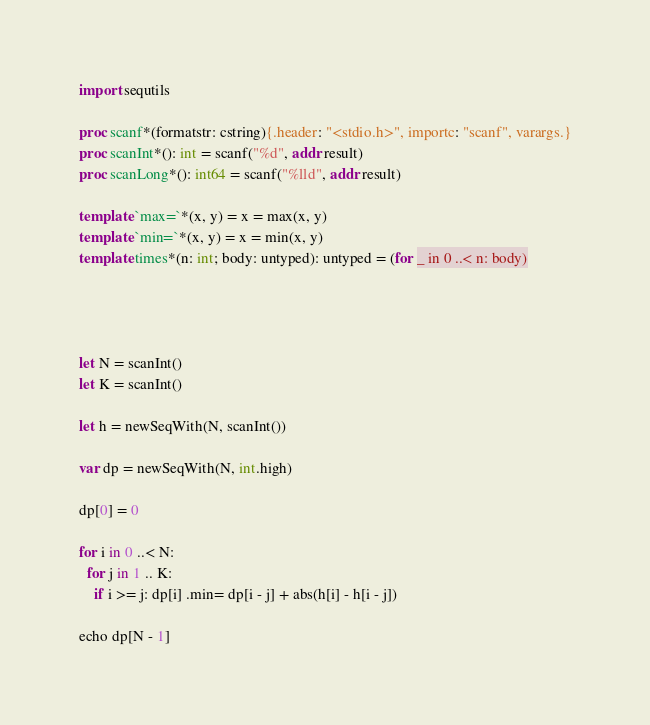<code> <loc_0><loc_0><loc_500><loc_500><_Nim_>import sequtils

proc scanf*(formatstr: cstring){.header: "<stdio.h>", importc: "scanf", varargs.}
proc scanInt*(): int = scanf("%d", addr result)
proc scanLong*(): int64 = scanf("%lld", addr result)

template `max=`*(x, y) = x = max(x, y)
template `min=`*(x, y) = x = min(x, y)
template times*(n: int; body: untyped): untyped = (for _ in 0 ..< n: body)




let N = scanInt()
let K = scanInt()

let h = newSeqWith(N, scanInt())

var dp = newSeqWith(N, int.high)

dp[0] = 0

for i in 0 ..< N:
  for j in 1 .. K:
    if i >= j: dp[i] .min= dp[i - j] + abs(h[i] - h[i - j])
    
echo dp[N - 1]
</code> 